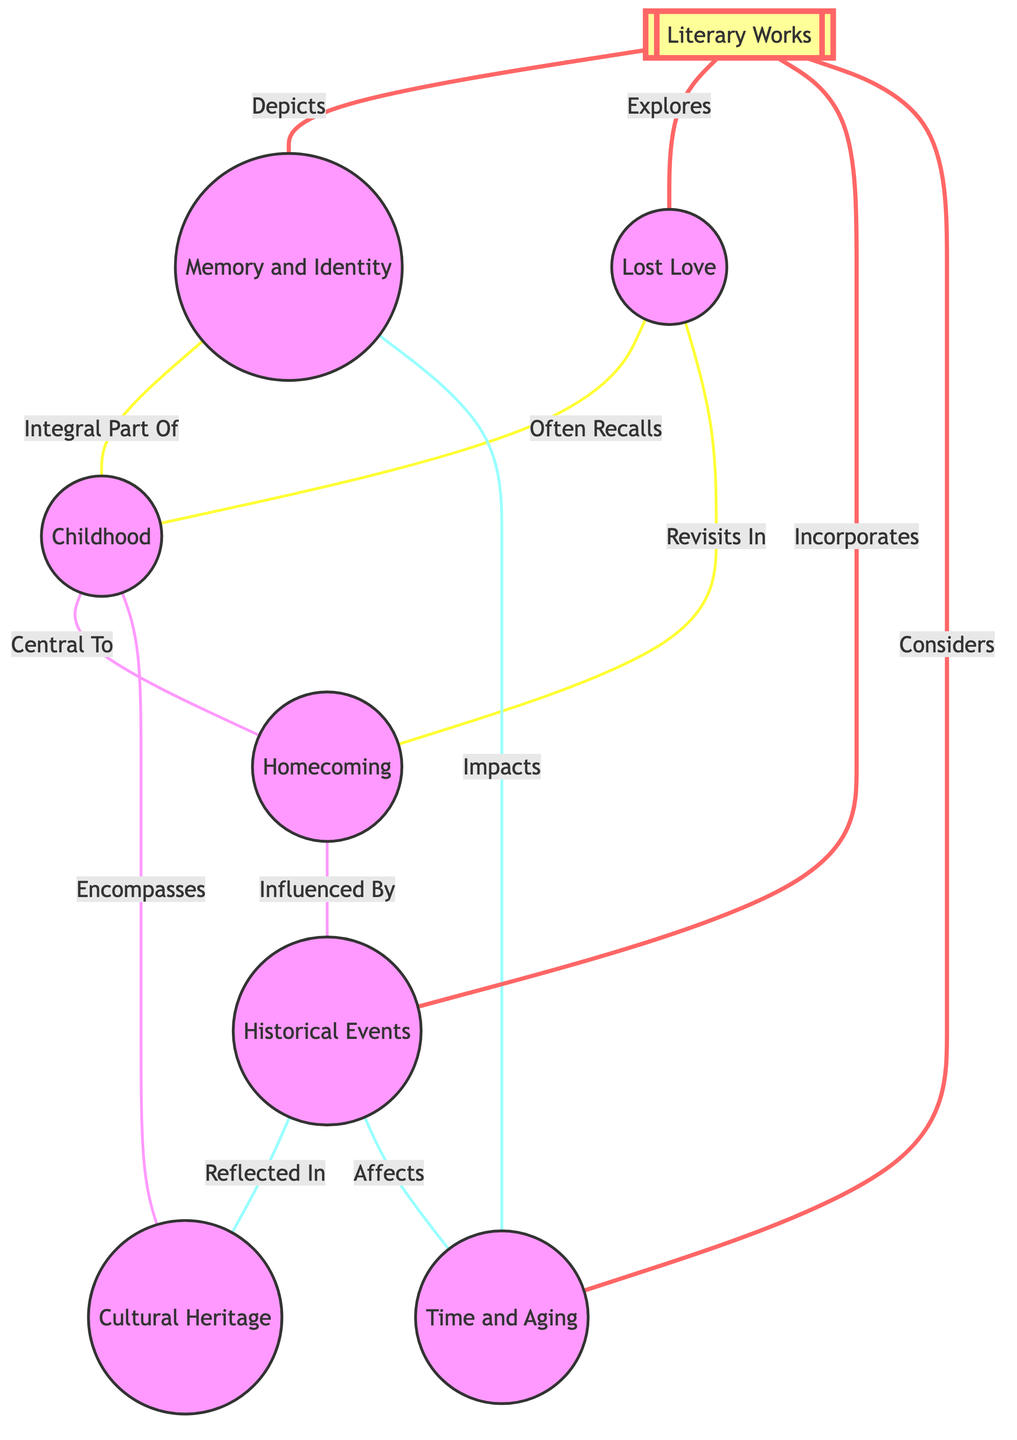What is the total number of nodes in the diagram? The diagram has eight nodes listed under the "nodes" section, specifically: Memory and Identity, Lost Love, Childhood, Homecoming, Historical Events, Cultural Heritage, Time and Aging, and Literary Works. Counting these gives a total of eight nodes.
Answer: 8 How many edges connect "Childhood" to other nodes? "Childhood" is connected to three other nodes: "Memory and Identity", "Homecoming", and "Cultural Heritage". Counting these connections gives a total of three edges.
Answer: 3 What is the relationship between "Lost Love" and "Homecoming"? The relationship is labeled "Revisits In", indicating that lost love is often revisited in the context of homecoming.
Answer: Revisits In Which theme impacts "Memory and Identity"? The theme that impacts "Memory and Identity" is "Time and Aging", as per the edge labeled "Impacts".
Answer: Time and Aging Which literary theme incorporates "Historical Events"? The literary theme that incorporates "Historical Events" is "Literary Works", as indicated by the edge labeled "Incorporates".
Answer: Literary Works How does "Childhood" relate to "Cultural Heritage"? The relationship between "Childhood" and "Cultural Heritage" is described by "Encompasses", meaning childhood experiences often encompass cultural heritage.
Answer: Encompasses What is the connection between "Homecoming" and "Historical Events"? "Homecoming" is influenced by "Historical Events", shown by the edge labeled "Influenced By".
Answer: Influenced By What are the two themes that "Literary Works" explores? "Literary Works" explores "Memory and Identity" and "Lost Love", as indicated by the edges labeled "Depicts" and "Explores".
Answer: Memory and Identity, Lost Love 